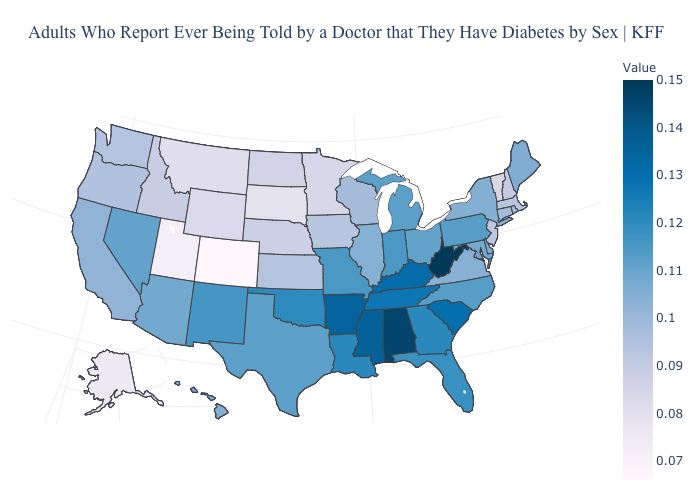Does the map have missing data?
Write a very short answer. No. Does North Dakota have the lowest value in the MidWest?
Quick response, please. No. Does the map have missing data?
Quick response, please. No. Among the states that border Delaware , does Pennsylvania have the highest value?
Give a very brief answer. Yes. Is the legend a continuous bar?
Write a very short answer. Yes. 